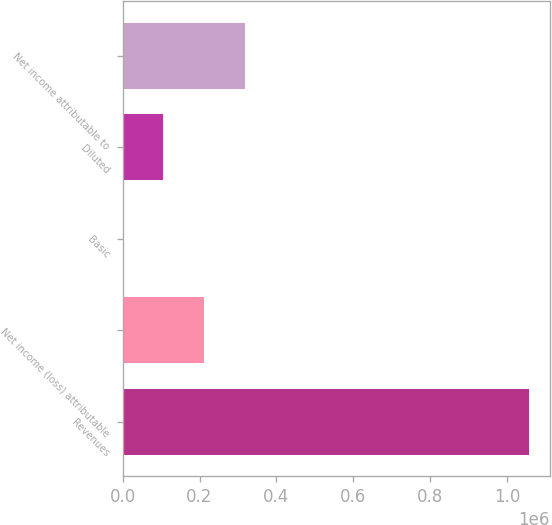<chart> <loc_0><loc_0><loc_500><loc_500><bar_chart><fcel>Revenues<fcel>Net income (loss) attributable<fcel>Basic<fcel>Diluted<fcel>Net income attributable to<nl><fcel>1.0586e+06<fcel>211721<fcel>0.51<fcel>105861<fcel>317581<nl></chart> 